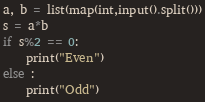<code> <loc_0><loc_0><loc_500><loc_500><_Python_>a, b = list(map(int,input().split()))
s = a*b
if s%2 == 0:
    print("Even")
else :
    print("Odd")</code> 